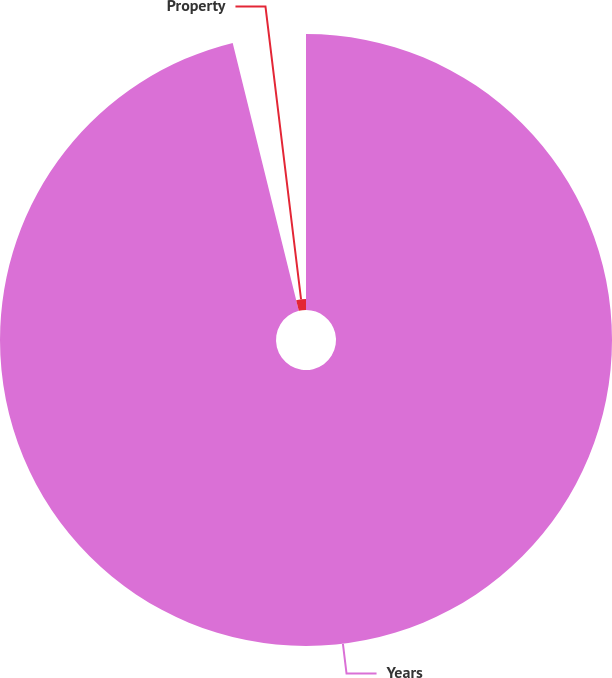Convert chart. <chart><loc_0><loc_0><loc_500><loc_500><pie_chart><fcel>Years<fcel>Property<nl><fcel>96.15%<fcel>3.85%<nl></chart> 